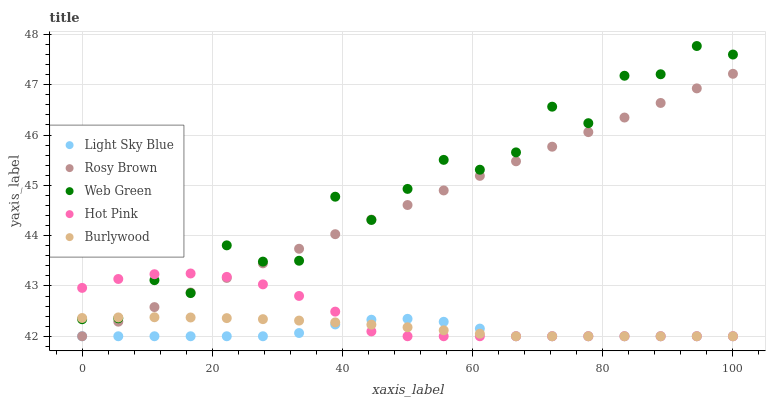Does Light Sky Blue have the minimum area under the curve?
Answer yes or no. Yes. Does Web Green have the maximum area under the curve?
Answer yes or no. Yes. Does Rosy Brown have the minimum area under the curve?
Answer yes or no. No. Does Rosy Brown have the maximum area under the curve?
Answer yes or no. No. Is Rosy Brown the smoothest?
Answer yes or no. Yes. Is Web Green the roughest?
Answer yes or no. Yes. Is Light Sky Blue the smoothest?
Answer yes or no. No. Is Light Sky Blue the roughest?
Answer yes or no. No. Does Burlywood have the lowest value?
Answer yes or no. Yes. Does Web Green have the lowest value?
Answer yes or no. No. Does Web Green have the highest value?
Answer yes or no. Yes. Does Rosy Brown have the highest value?
Answer yes or no. No. Is Light Sky Blue less than Web Green?
Answer yes or no. Yes. Is Web Green greater than Light Sky Blue?
Answer yes or no. Yes. Does Rosy Brown intersect Light Sky Blue?
Answer yes or no. Yes. Is Rosy Brown less than Light Sky Blue?
Answer yes or no. No. Is Rosy Brown greater than Light Sky Blue?
Answer yes or no. No. Does Light Sky Blue intersect Web Green?
Answer yes or no. No. 